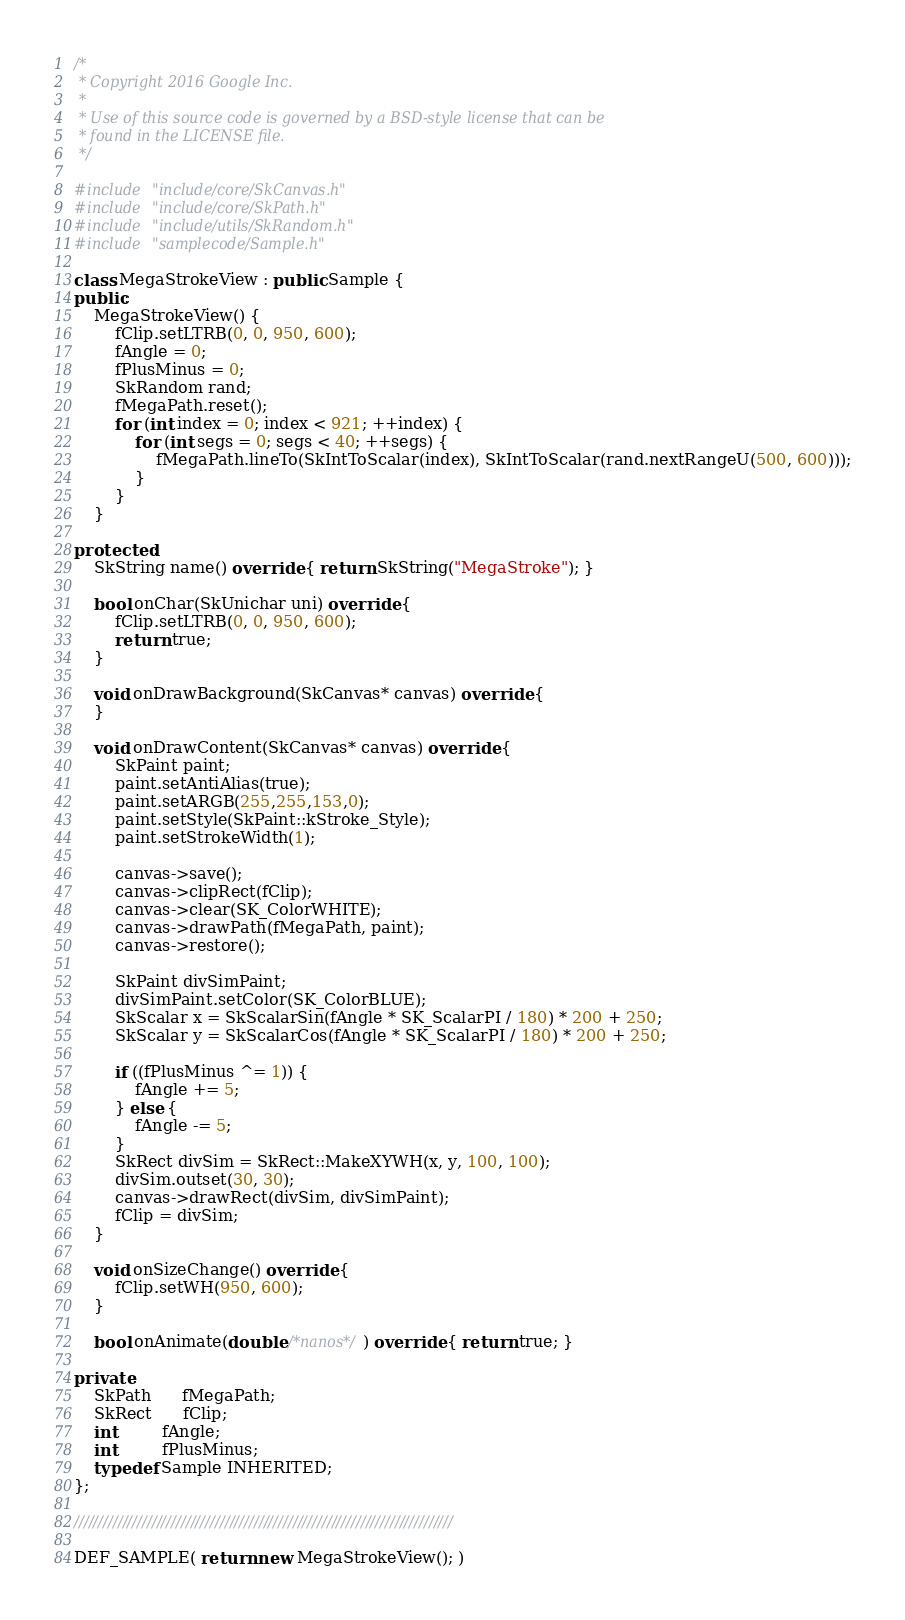<code> <loc_0><loc_0><loc_500><loc_500><_C++_>/*
 * Copyright 2016 Google Inc.
 *
 * Use of this source code is governed by a BSD-style license that can be
 * found in the LICENSE file.
 */

#include "include/core/SkCanvas.h"
#include "include/core/SkPath.h"
#include "include/utils/SkRandom.h"
#include "samplecode/Sample.h"

class MegaStrokeView : public Sample {
public:
    MegaStrokeView() {
        fClip.setLTRB(0, 0, 950, 600);
        fAngle = 0;
        fPlusMinus = 0;
        SkRandom rand;
        fMegaPath.reset();
        for (int index = 0; index < 921; ++index) {
            for (int segs = 0; segs < 40; ++segs) {
                fMegaPath.lineTo(SkIntToScalar(index), SkIntToScalar(rand.nextRangeU(500, 600)));
            }
        }
    }

protected:
    SkString name() override { return SkString("MegaStroke"); }

    bool onChar(SkUnichar uni) override {
        fClip.setLTRB(0, 0, 950, 600);
        return true;
    }

    void onDrawBackground(SkCanvas* canvas) override {
    }

    void onDrawContent(SkCanvas* canvas) override {
        SkPaint paint;
        paint.setAntiAlias(true);
        paint.setARGB(255,255,153,0);
        paint.setStyle(SkPaint::kStroke_Style);
        paint.setStrokeWidth(1);

        canvas->save();
        canvas->clipRect(fClip);
        canvas->clear(SK_ColorWHITE);
        canvas->drawPath(fMegaPath, paint);
        canvas->restore();

        SkPaint divSimPaint;
        divSimPaint.setColor(SK_ColorBLUE);
	    SkScalar x = SkScalarSin(fAngle * SK_ScalarPI / 180) * 200 + 250;
	    SkScalar y = SkScalarCos(fAngle * SK_ScalarPI / 180) * 200 + 250;

        if ((fPlusMinus ^= 1)) {
            fAngle += 5;
        } else {
            fAngle -= 5;
        }
        SkRect divSim = SkRect::MakeXYWH(x, y, 100, 100);
        divSim.outset(30, 30);
        canvas->drawRect(divSim, divSimPaint);
        fClip = divSim;
    }

    void onSizeChange() override {
        fClip.setWH(950, 600);
    }

    bool onAnimate(double /*nanos*/) override { return true; }

private:
    SkPath      fMegaPath;
    SkRect      fClip;
    int         fAngle;
    int         fPlusMinus;
    typedef Sample INHERITED;
};

//////////////////////////////////////////////////////////////////////////////

DEF_SAMPLE( return new MegaStrokeView(); )
</code> 